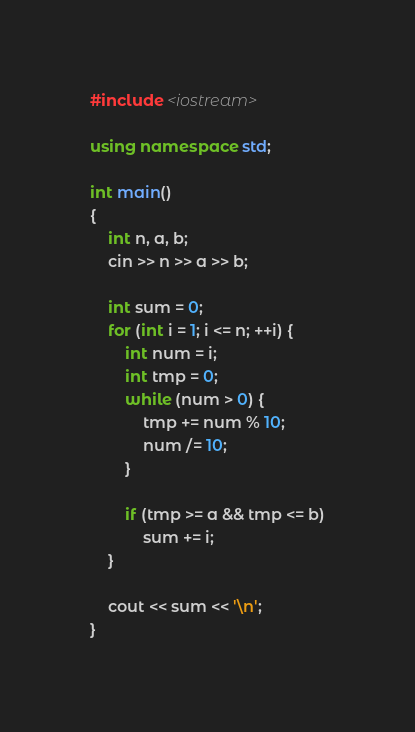<code> <loc_0><loc_0><loc_500><loc_500><_C++_>#include <iostream>

using namespace std;

int main()
{
    int n, a, b;
    cin >> n >> a >> b;

    int sum = 0;
    for (int i = 1; i <= n; ++i) {
        int num = i;
        int tmp = 0;
        while (num > 0) {
            tmp += num % 10;
            num /= 10;
        }

        if (tmp >= a && tmp <= b)
            sum += i;
    }

    cout << sum << '\n';
}
</code> 